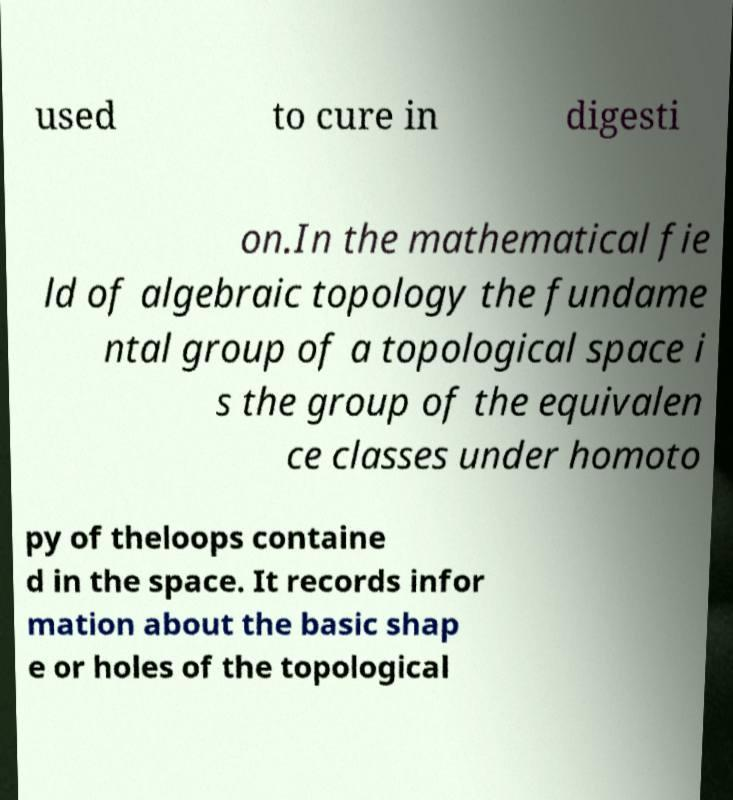I need the written content from this picture converted into text. Can you do that? used to cure in digesti on.In the mathematical fie ld of algebraic topology the fundame ntal group of a topological space i s the group of the equivalen ce classes under homoto py of theloops containe d in the space. It records infor mation about the basic shap e or holes of the topological 